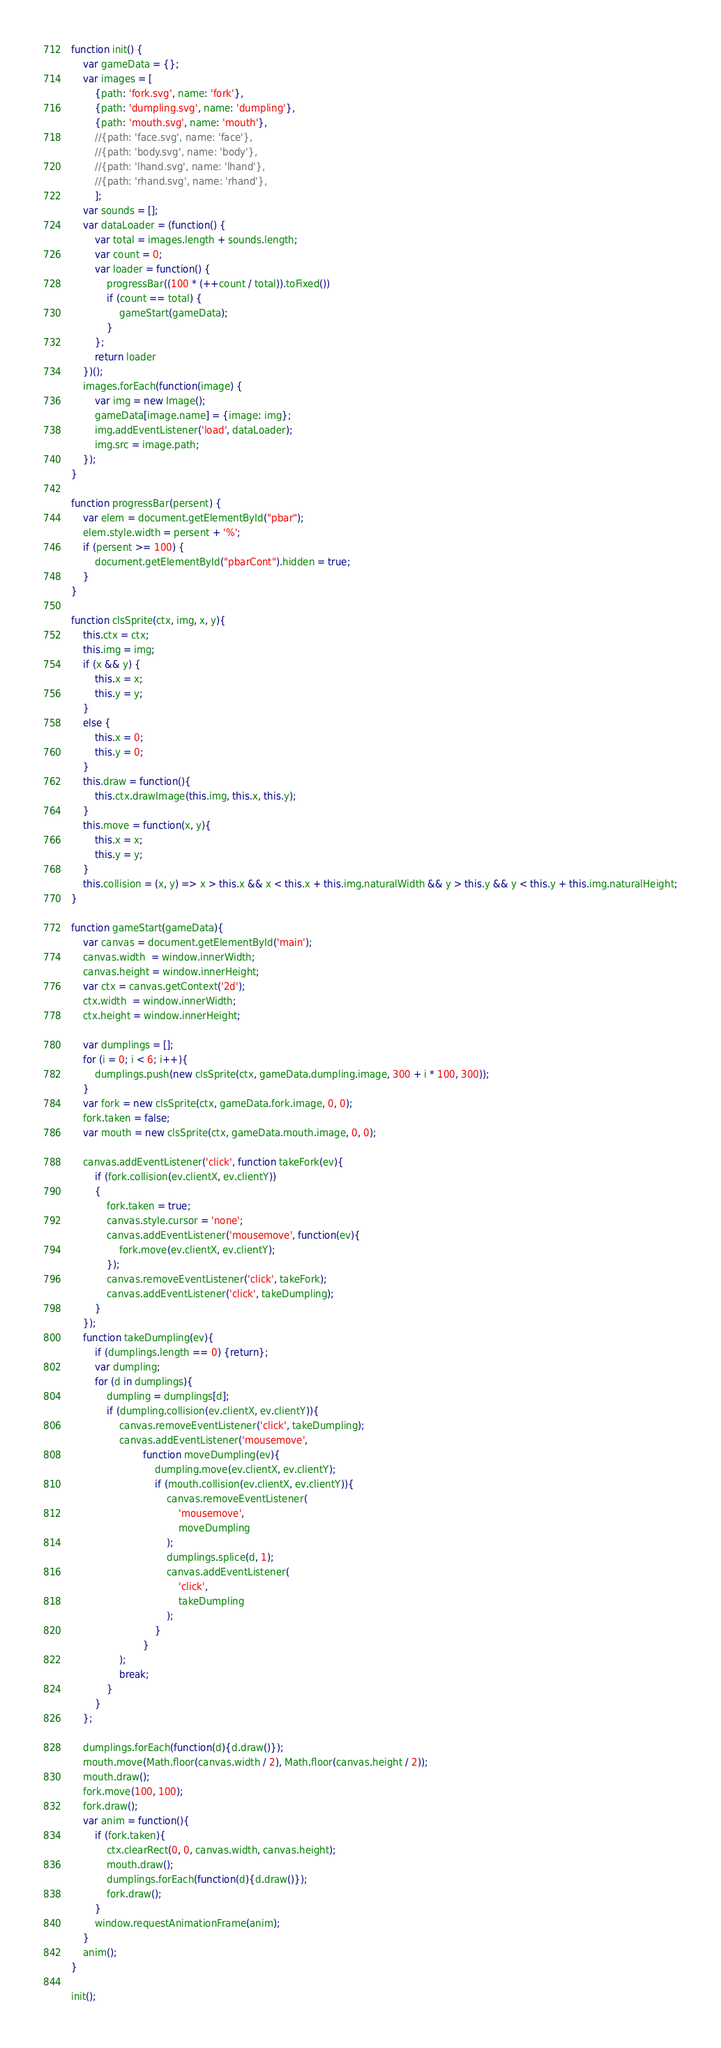Convert code to text. <code><loc_0><loc_0><loc_500><loc_500><_JavaScript_>function init() {
    var gameData = {};
    var images = [
        {path: 'fork.svg', name: 'fork'},
        {path: 'dumpling.svg', name: 'dumpling'},
        {path: 'mouth.svg', name: 'mouth'},
        //{path: 'face.svg', name: 'face'},
        //{path: 'body.svg', name: 'body'},
        //{path: 'lhand.svg', name: 'lhand'},
        //{path: 'rhand.svg', name: 'rhand'},
        ];
    var sounds = [];
    var dataLoader = (function() {
        var total = images.length + sounds.length;
        var count = 0;
        var loader = function() {
            progressBar((100 * (++count / total)).toFixed())
            if (count == total) {
                gameStart(gameData);
            }
        };
        return loader
    })();
    images.forEach(function(image) {
        var img = new Image();
        gameData[image.name] = {image: img};
        img.addEventListener('load', dataLoader);
        img.src = image.path;
    });
}

function progressBar(persent) {
    var elem = document.getElementById("pbar");
    elem.style.width = persent + '%';
    if (persent >= 100) {
        document.getElementById("pbarCont").hidden = true;
    }
}

function clsSprite(ctx, img, x, y){
    this.ctx = ctx;
    this.img = img;
    if (x && y) {
        this.x = x;
        this.y = y;
    }
    else {
        this.x = 0;
        this.y = 0;
    }
    this.draw = function(){
        this.ctx.drawImage(this.img, this.x, this.y);
    } 
    this.move = function(x, y){
        this.x = x;
        this.y = y;
    }
    this.collision = (x, y) => x > this.x && x < this.x + this.img.naturalWidth && y > this.y && y < this.y + this.img.naturalHeight;
}

function gameStart(gameData){
    var canvas = document.getElementById('main');
    canvas.width  = window.innerWidth;
    canvas.height = window.innerHeight;
    var ctx = canvas.getContext('2d');
    ctx.width  = window.innerWidth;
    ctx.height = window.innerHeight;

    var dumplings = [];
    for (i = 0; i < 6; i++){
        dumplings.push(new clsSprite(ctx, gameData.dumpling.image, 300 + i * 100, 300));
    }
    var fork = new clsSprite(ctx, gameData.fork.image, 0, 0);
    fork.taken = false;
    var mouth = new clsSprite(ctx, gameData.mouth.image, 0, 0);

    canvas.addEventListener('click', function takeFork(ev){
        if (fork.collision(ev.clientX, ev.clientY))
        {
            fork.taken = true;
            canvas.style.cursor = 'none';
            canvas.addEventListener('mousemove', function(ev){
                fork.move(ev.clientX, ev.clientY);
            });
            canvas.removeEventListener('click', takeFork);
            canvas.addEventListener('click', takeDumpling);
        }
    });
    function takeDumpling(ev){
        if (dumplings.length == 0) {return};
        var dumpling;
        for (d in dumplings){
            dumpling = dumplings[d];
            if (dumpling.collision(ev.clientX, ev.clientY)){
                canvas.removeEventListener('click', takeDumpling);
                canvas.addEventListener('mousemove',
                        function moveDumpling(ev){
                            dumpling.move(ev.clientX, ev.clientY);
                            if (mouth.collision(ev.clientX, ev.clientY)){
                                canvas.removeEventListener(
                                    'mousemove',
                                    moveDumpling
                                );
                                dumplings.splice(d, 1);
                                canvas.addEventListener(
                                    'click',
                                    takeDumpling
                                );
                            }
                        }
                );
                break;
            }
        }
    };

    dumplings.forEach(function(d){d.draw()});
    mouth.move(Math.floor(canvas.width / 2), Math.floor(canvas.height / 2));
    mouth.draw();
    fork.move(100, 100);
    fork.draw();
    var anim = function(){
        if (fork.taken){
            ctx.clearRect(0, 0, canvas.width, canvas.height);
            mouth.draw();
            dumplings.forEach(function(d){d.draw()});
            fork.draw();
        }
        window.requestAnimationFrame(anim);
    }
    anim();
}

init();
</code> 